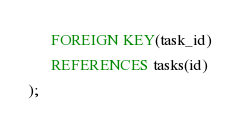<code> <loc_0><loc_0><loc_500><loc_500><_SQL_>      FOREIGN KEY(task_id)
	  REFERENCES tasks(id)
);</code> 